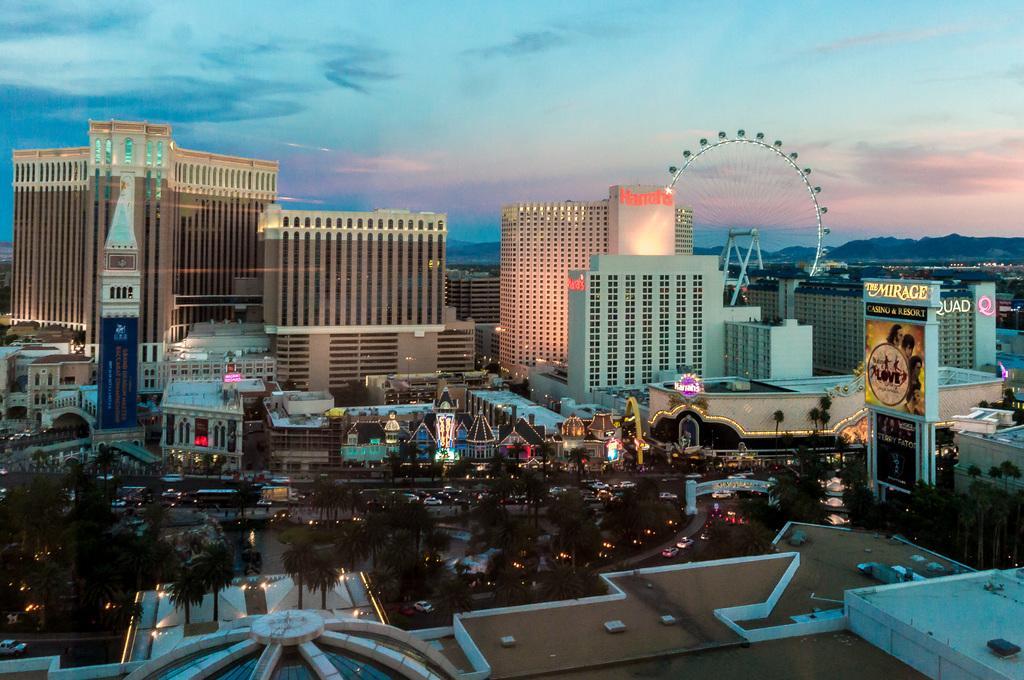Could you give a brief overview of what you see in this image? In this image there are buildings, trees, vehicles and there are mountains and the sky is cloudy and on the right side there is a board with some text written on it. 